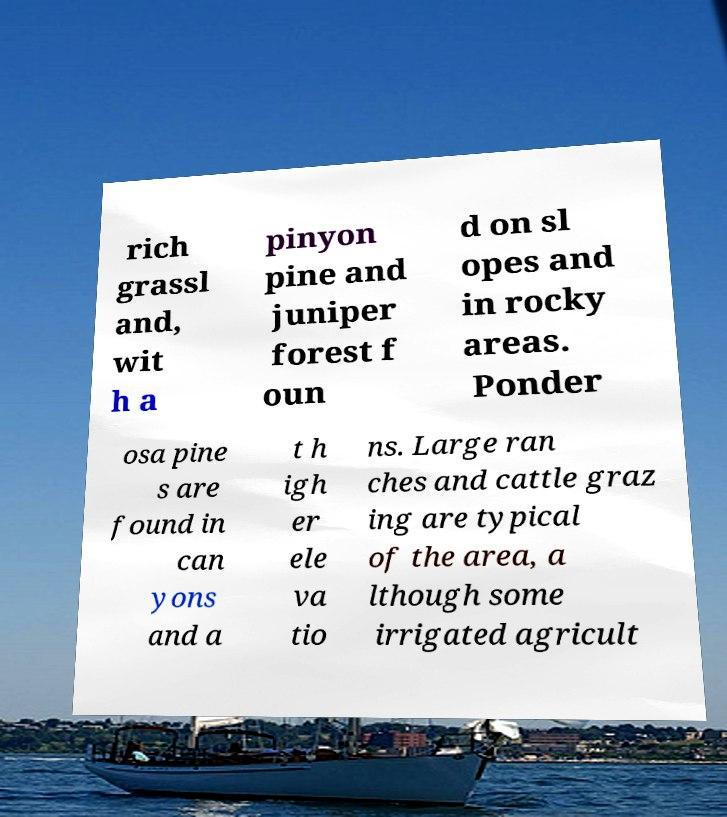Could you extract and type out the text from this image? rich grassl and, wit h a pinyon pine and juniper forest f oun d on sl opes and in rocky areas. Ponder osa pine s are found in can yons and a t h igh er ele va tio ns. Large ran ches and cattle graz ing are typical of the area, a lthough some irrigated agricult 